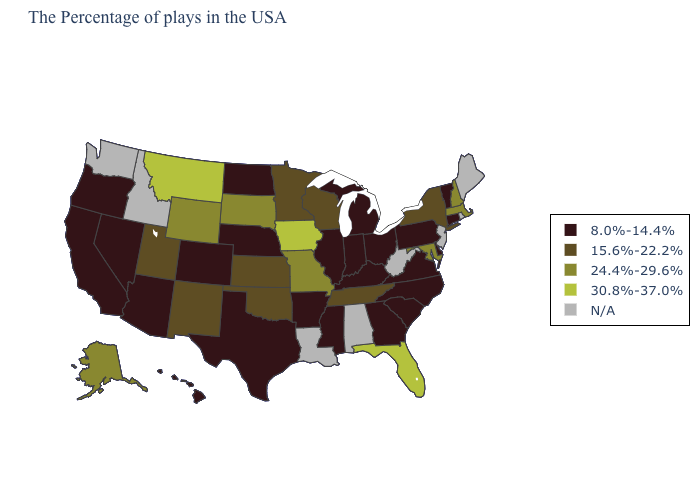What is the value of Oklahoma?
Short answer required. 15.6%-22.2%. Which states have the lowest value in the USA?
Answer briefly. Vermont, Connecticut, Delaware, Pennsylvania, Virginia, North Carolina, South Carolina, Ohio, Georgia, Michigan, Kentucky, Indiana, Illinois, Mississippi, Arkansas, Nebraska, Texas, North Dakota, Colorado, Arizona, Nevada, California, Oregon, Hawaii. What is the value of Maine?
Give a very brief answer. N/A. Among the states that border Louisiana , which have the lowest value?
Concise answer only. Mississippi, Arkansas, Texas. What is the lowest value in states that border Arizona?
Keep it brief. 8.0%-14.4%. Which states hav the highest value in the South?
Concise answer only. Florida. Name the states that have a value in the range 15.6%-22.2%?
Answer briefly. New York, Tennessee, Wisconsin, Minnesota, Kansas, Oklahoma, New Mexico, Utah. Does Montana have the highest value in the USA?
Answer briefly. Yes. What is the highest value in states that border Texas?
Be succinct. 15.6%-22.2%. What is the value of Oklahoma?
Quick response, please. 15.6%-22.2%. Is the legend a continuous bar?
Keep it brief. No. Among the states that border Iowa , does Nebraska have the highest value?
Write a very short answer. No. 